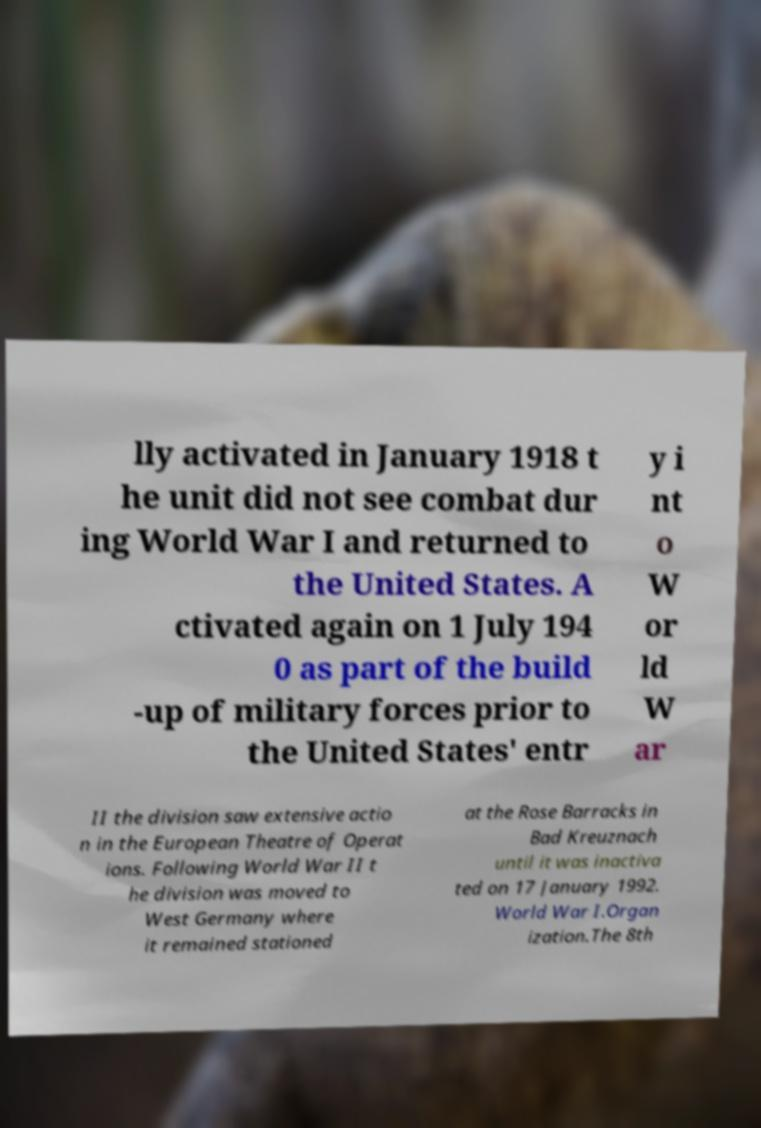Can you read and provide the text displayed in the image?This photo seems to have some interesting text. Can you extract and type it out for me? lly activated in January 1918 t he unit did not see combat dur ing World War I and returned to the United States. A ctivated again on 1 July 194 0 as part of the build -up of military forces prior to the United States' entr y i nt o W or ld W ar II the division saw extensive actio n in the European Theatre of Operat ions. Following World War II t he division was moved to West Germany where it remained stationed at the Rose Barracks in Bad Kreuznach until it was inactiva ted on 17 January 1992. World War I.Organ ization.The 8th 